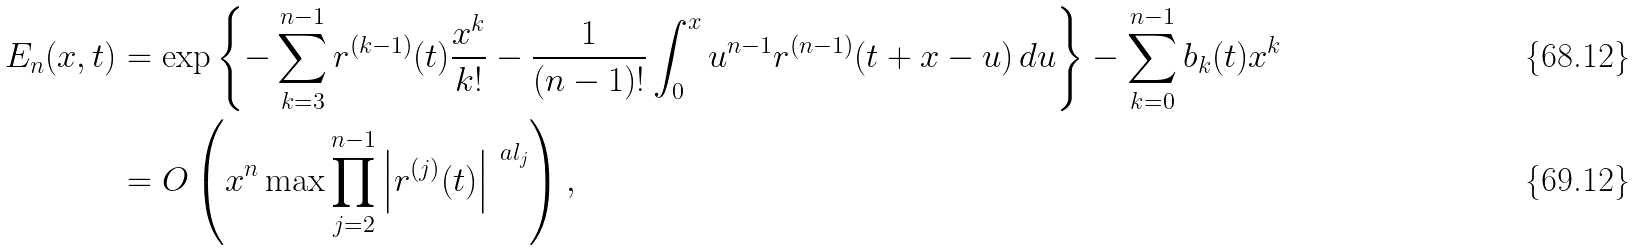<formula> <loc_0><loc_0><loc_500><loc_500>E _ { n } ( x , t ) & = \exp \left \{ - \sum _ { k = 3 } ^ { n - 1 } r ^ { ( k - 1 ) } ( t ) \frac { x ^ { k } } { k ! } - \frac { 1 } { ( n - 1 ) ! } \int _ { 0 } ^ { x } u ^ { n - 1 } r ^ { ( n - 1 ) } ( t + x - u ) \, d u \right \} - \sum _ { k = 0 } ^ { n - 1 } b _ { k } ( t ) x ^ { k } \\ & = O \left ( x ^ { n } \max \prod _ { j = 2 } ^ { n - 1 } \left | r ^ { ( j ) } ( t ) \right | ^ { \ a l _ { j } } \right ) ,</formula> 